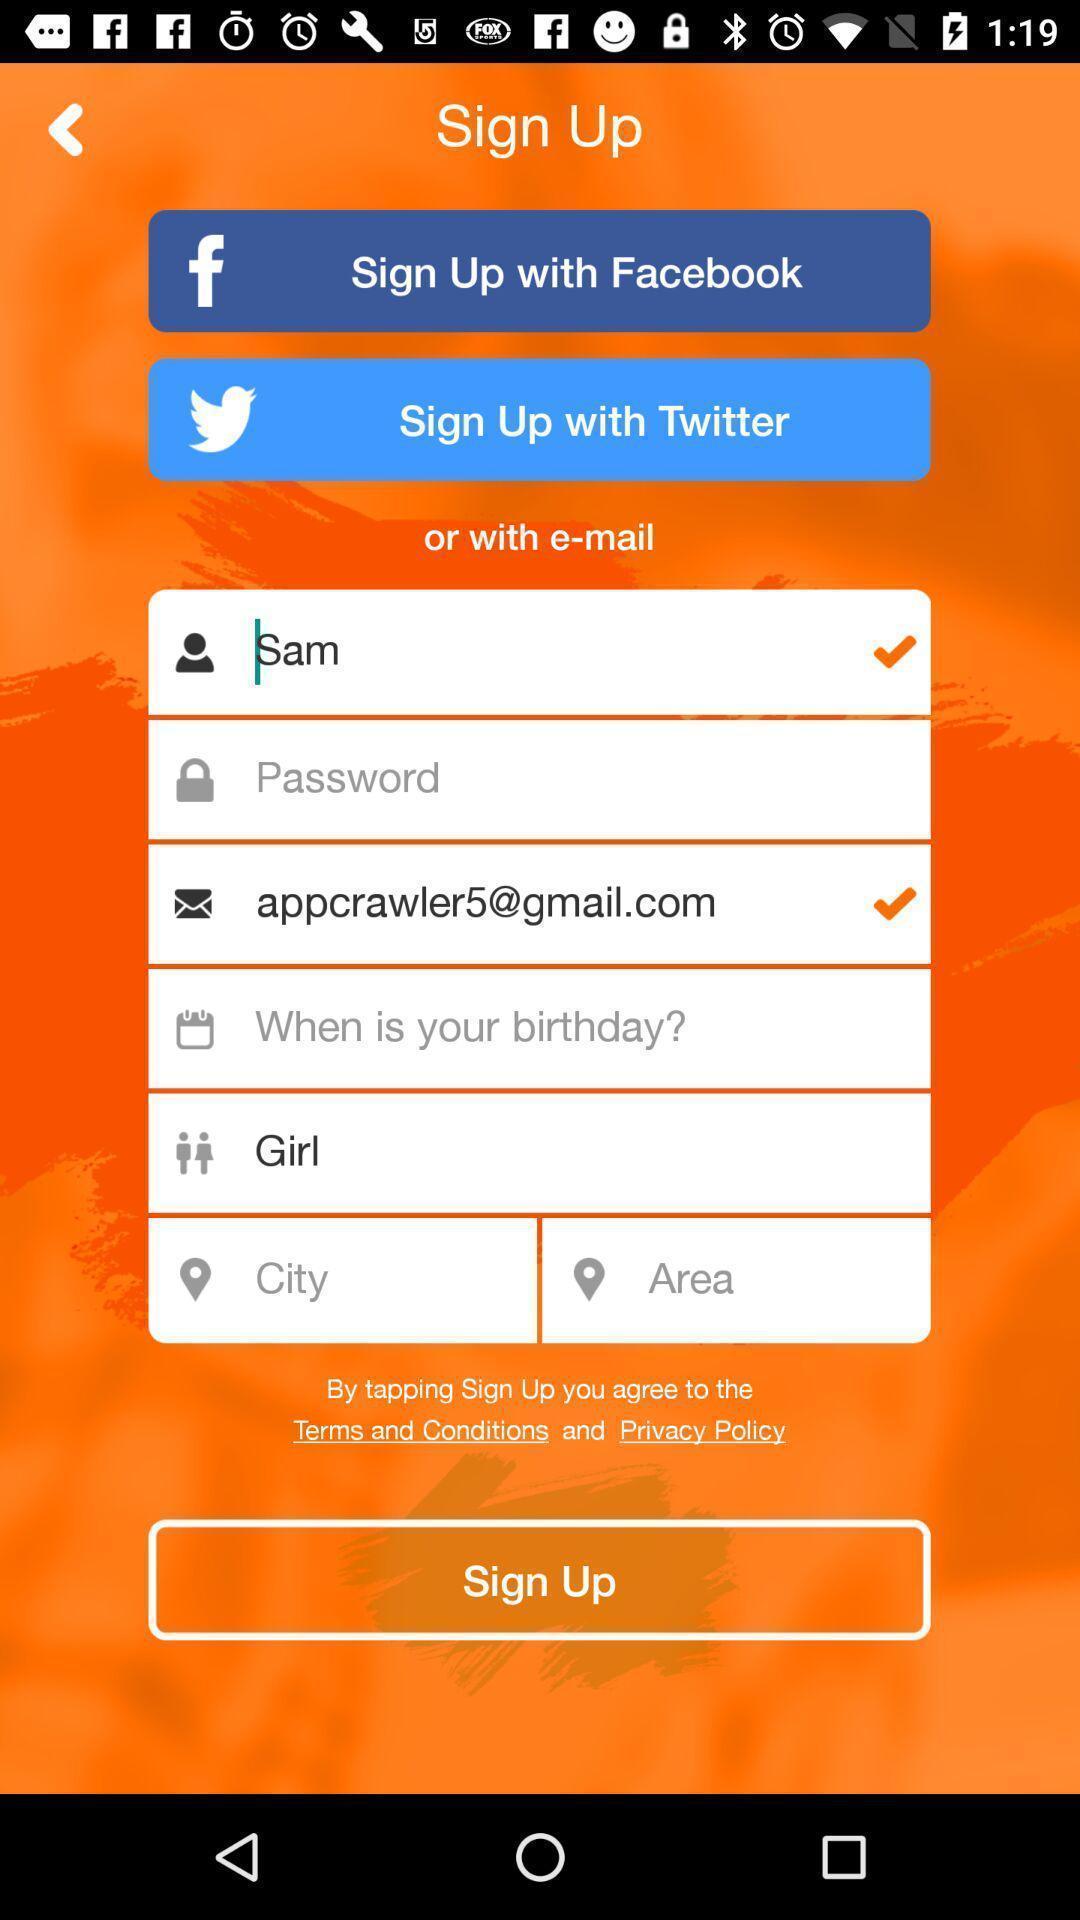Summarize the information in this screenshot. Welcome to the sign up page. 